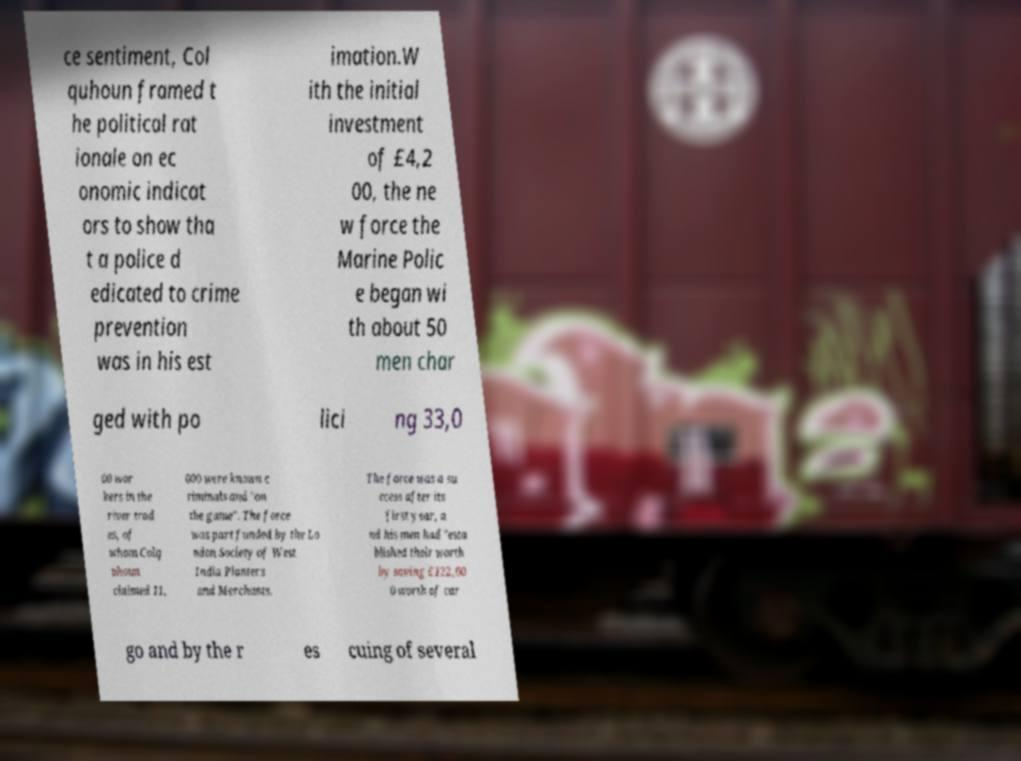What messages or text are displayed in this image? I need them in a readable, typed format. ce sentiment, Col quhoun framed t he political rat ionale on ec onomic indicat ors to show tha t a police d edicated to crime prevention was in his est imation.W ith the initial investment of £4,2 00, the ne w force the Marine Polic e began wi th about 50 men char ged with po lici ng 33,0 00 wor kers in the river trad es, of whom Colq uhoun claimed 11, 000 were known c riminals and "on the game". The force was part funded by the Lo ndon Society of West India Planters and Merchants. The force was a su ccess after its first year, a nd his men had "esta blished their worth by saving £122,00 0 worth of car go and by the r es cuing of several 